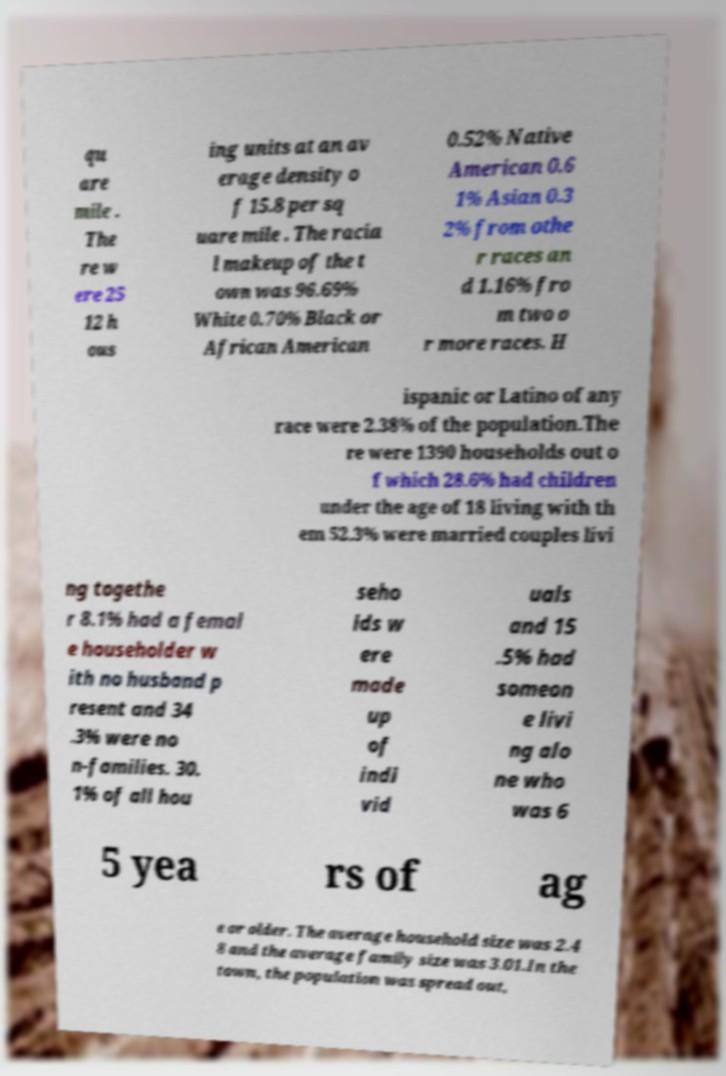Could you extract and type out the text from this image? qu are mile . The re w ere 25 12 h ous ing units at an av erage density o f 15.8 per sq uare mile . The racia l makeup of the t own was 96.69% White 0.70% Black or African American 0.52% Native American 0.6 1% Asian 0.3 2% from othe r races an d 1.16% fro m two o r more races. H ispanic or Latino of any race were 2.38% of the population.The re were 1390 households out o f which 28.6% had children under the age of 18 living with th em 52.3% were married couples livi ng togethe r 8.1% had a femal e householder w ith no husband p resent and 34 .3% were no n-families. 30. 1% of all hou seho lds w ere made up of indi vid uals and 15 .5% had someon e livi ng alo ne who was 6 5 yea rs of ag e or older. The average household size was 2.4 8 and the average family size was 3.01.In the town, the population was spread out, 